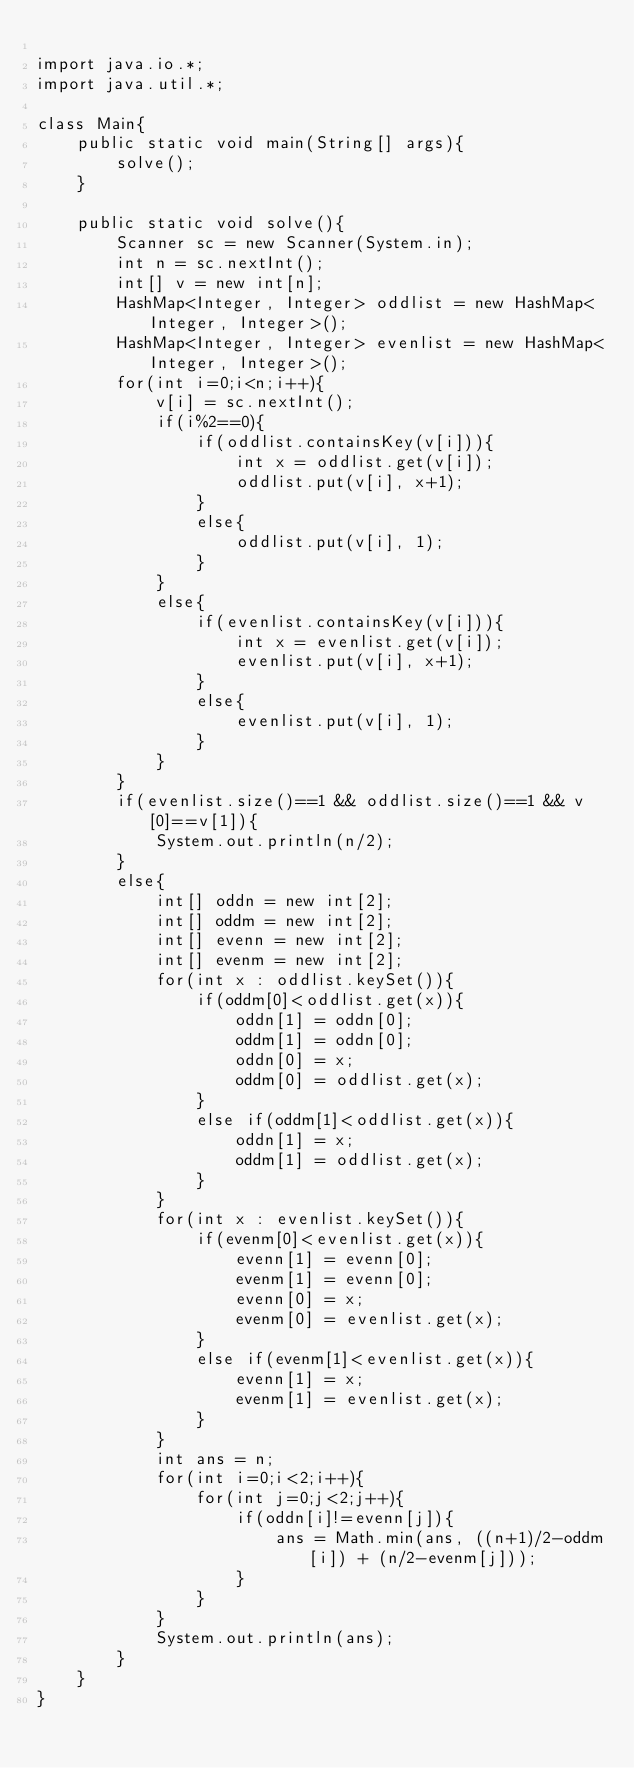Convert code to text. <code><loc_0><loc_0><loc_500><loc_500><_Java_>
import java.io.*;
import java.util.*;

class Main{
    public static void main(String[] args){
        solve();
    }

    public static void solve(){
        Scanner sc = new Scanner(System.in);
        int n = sc.nextInt();
        int[] v = new int[n];
        HashMap<Integer, Integer> oddlist = new HashMap<Integer, Integer>();
        HashMap<Integer, Integer> evenlist = new HashMap<Integer, Integer>();
        for(int i=0;i<n;i++){
        	v[i] = sc.nextInt();
        	if(i%2==0){
	        	if(oddlist.containsKey(v[i])){
    	    		int x = oddlist.get(v[i]);
        			oddlist.put(v[i], x+1);
        		}
        		else{
        			oddlist.put(v[i], 1);
        		}
        	}
        	else{
        		if(evenlist.containsKey(v[i])){
    	    		int x = evenlist.get(v[i]);
        			evenlist.put(v[i], x+1);
        		}
        		else{
        			evenlist.put(v[i], 1);
        		}	
        	}
        }
        if(evenlist.size()==1 && oddlist.size()==1 && v[0]==v[1]){
        	System.out.println(n/2);
        }
        else{
        	int[] oddn = new int[2];
        	int[] oddm = new int[2];
        	int[] evenn = new int[2];
        	int[] evenm = new int[2];
        	for(int x : oddlist.keySet()){
        		if(oddm[0]<oddlist.get(x)){
        			oddn[1] = oddn[0];
        			oddm[1] = oddn[0];
        			oddn[0] = x;
        			oddm[0] = oddlist.get(x);
        		}
        		else if(oddm[1]<oddlist.get(x)){
        			oddn[1] = x;
        			oddm[1] = oddlist.get(x);
        		}
        	}
        	for(int x : evenlist.keySet()){
        		if(evenm[0]<evenlist.get(x)){
        			evenn[1] = evenn[0];
        			evenm[1] = evenn[0];
        			evenn[0] = x;
        			evenm[0] = evenlist.get(x);
        		}
        		else if(evenm[1]<evenlist.get(x)){
        			evenn[1] = x;
        			evenm[1] = evenlist.get(x);
        		}
        	}
        	int ans = n;
        	for(int i=0;i<2;i++){
        		for(int j=0;j<2;j++){
        			if(oddn[i]!=evenn[j]){
        				ans = Math.min(ans, ((n+1)/2-oddm[i]) + (n/2-evenm[j]));
        			}
        		}
        	}
        	System.out.println(ans);
        }
    }
}</code> 